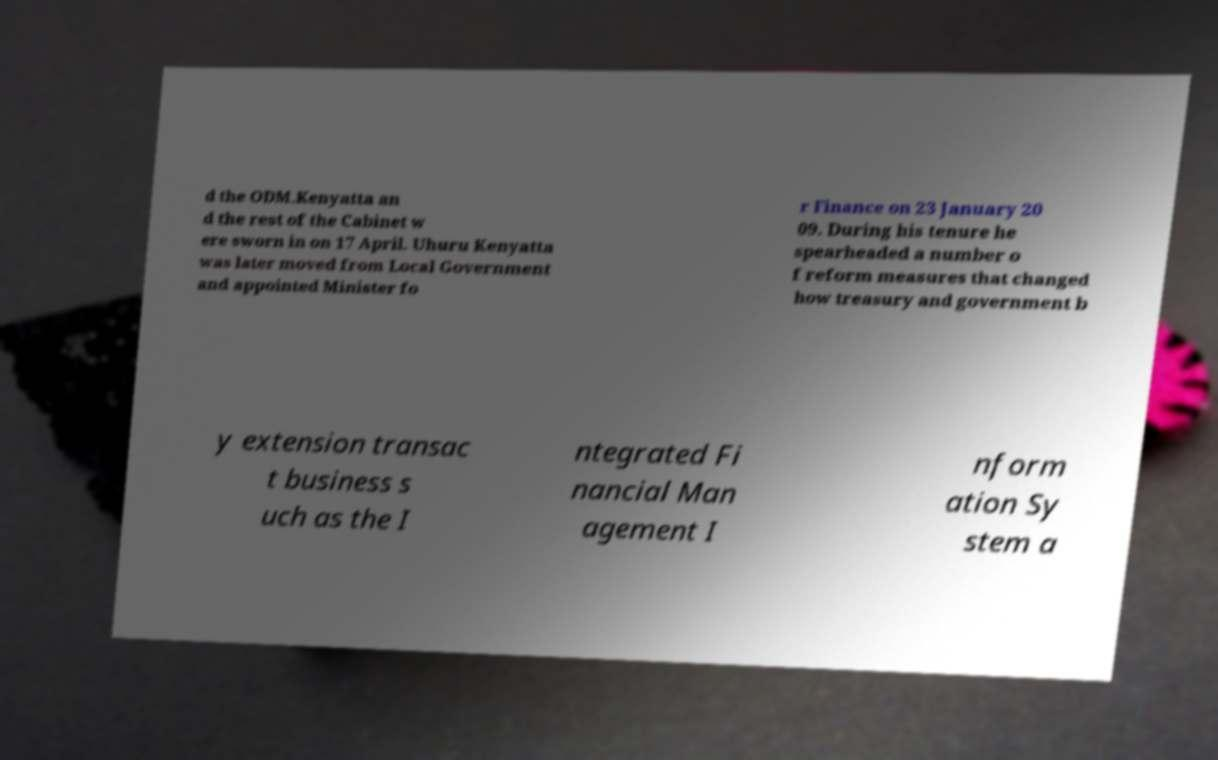Can you read and provide the text displayed in the image?This photo seems to have some interesting text. Can you extract and type it out for me? d the ODM.Kenyatta an d the rest of the Cabinet w ere sworn in on 17 April. Uhuru Kenyatta was later moved from Local Government and appointed Minister fo r Finance on 23 January 20 09. During his tenure he spearheaded a number o f reform measures that changed how treasury and government b y extension transac t business s uch as the I ntegrated Fi nancial Man agement I nform ation Sy stem a 